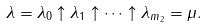Convert formula to latex. <formula><loc_0><loc_0><loc_500><loc_500>\lambda = \lambda _ { 0 } \uparrow \lambda _ { 1 } \uparrow \cdots \uparrow \lambda _ { m _ { 2 } } = \mu .</formula> 